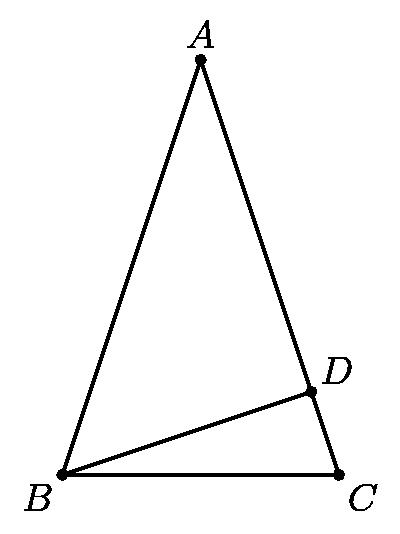How do the integer values of AD and CD influence the problem on computing the minimal AC? The integer values of AD and CD simplify the problem by restricting the possible dimensions to whole numbers, which are easier to handle analytically. This constraint significantly narrows down the choices when applying the Pythagorean theorem in triangles, such as ADB and BDC, to find a minimal value for AC while ensuring all sides comply with the integer condition. 